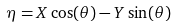Convert formula to latex. <formula><loc_0><loc_0><loc_500><loc_500>\eta = X \cos ( \theta ) - Y \sin ( \theta )</formula> 